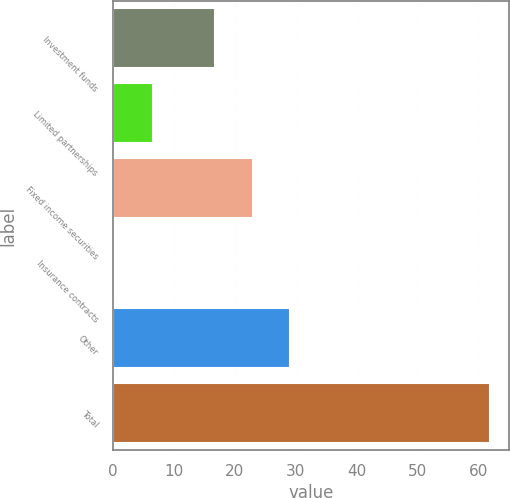Convert chart to OTSL. <chart><loc_0><loc_0><loc_500><loc_500><bar_chart><fcel>Investment funds<fcel>Limited partnerships<fcel>Fixed income securities<fcel>Insurance contracts<fcel>Other<fcel>Total<nl><fcel>16.8<fcel>6.59<fcel>22.95<fcel>0.45<fcel>29.09<fcel>61.9<nl></chart> 